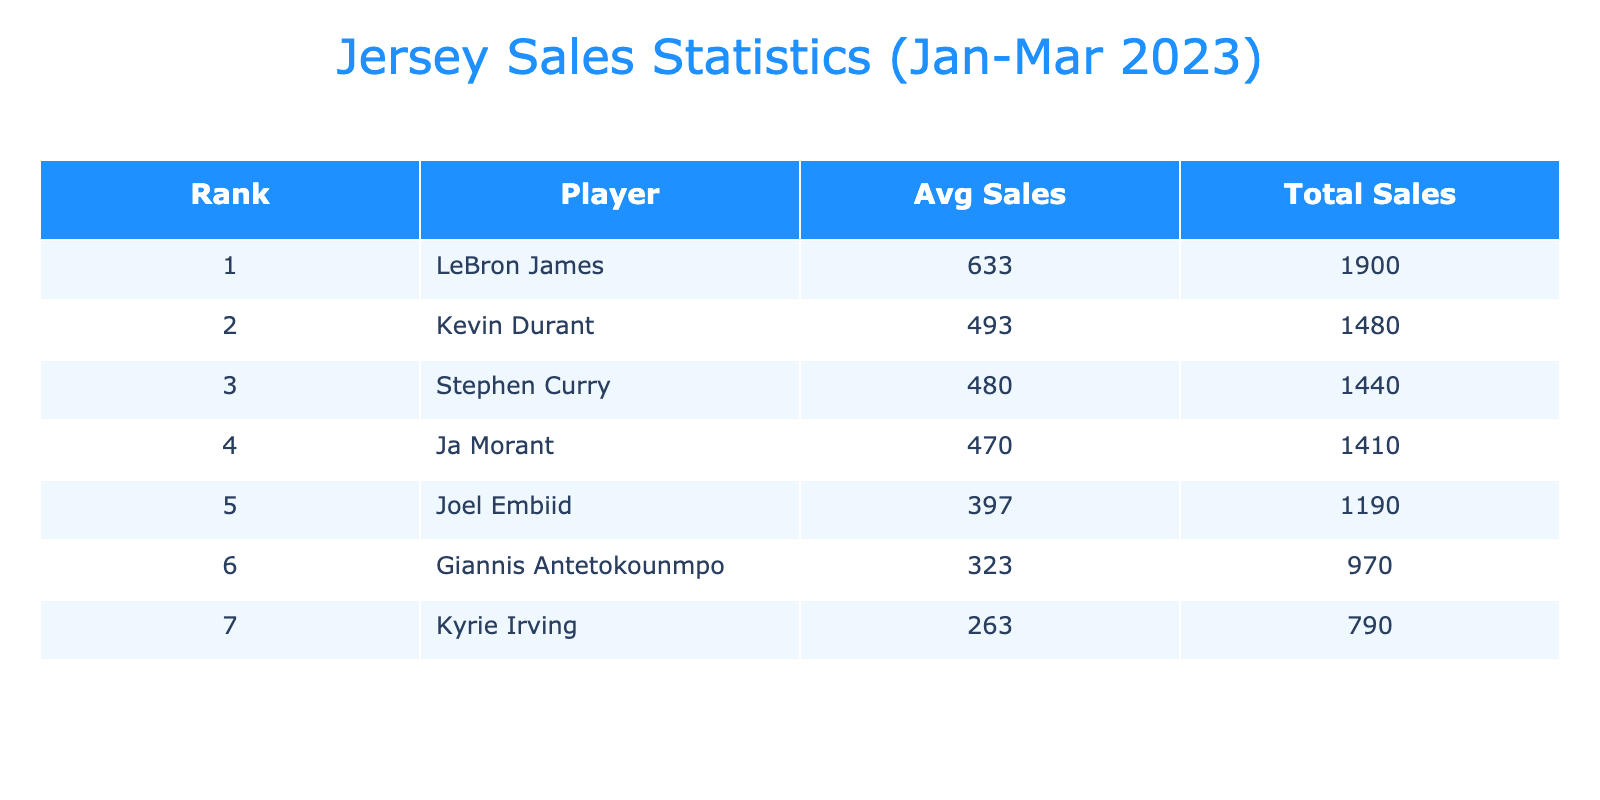What is the total jersey sales for LeBron James? From the table, we see that LeBron James has total sales of 580 + 620 + 700 = 1900.
Answer: 1900 Who had the highest average jersey sales? To determine this, we look at the average sales calculated in the table for each player. LeBron James has an average of 633.33, which is higher than any other player.
Answer: LeBron James Is the total jersey sales for Kyrie Irving greater than 800? The total sales for Kyrie Irving are 240 + 260 + 290 = 790, which is not greater than 800.
Answer: No What is the difference in average jersey sales between Stephen Curry and Kevin Durant? The average for Stephen Curry is 480, and for Kevin Durant, it is 493.33. The difference is 493.33 - 480 = 13.33.
Answer: 13.33 Which player had a rank of 3 in total sales? From the table, we see the ranks assigned to each player based on total sales, and Kevin Durant is ranked 3rd.
Answer: Kevin Durant Is the total sales of Giannis Antetokounmpo higher than that of Ja Morant? For Giannis, total sales are 300 + 320 + 350 = 970, and for Ja Morant, total sales are 410 + 480 + 520 = 1410. Since 970 is less than 1410, the answer is no.
Answer: No What is the combined average sales for all players in January? We sum the January sales: 580 (LeBron) + 450 (Stephen) + 430 (Kevin) + 300 (Giannis) + 240 (Kyrie) + 410 (Ja) + 370 (Joel) = 2880. There are 7 players, so the average is 2880 / 7 = 411.43.
Answer: 411.43 What was the total sales of all players in March? Adding the sales for March: 700 (LeBron) + 510 (Stephen) + 550 (Kevin) + 350 (Giannis) + 290 (Kyrie) + 520 (Ja) + 430 (Joel) = 3850.
Answer: 3850 Which player had a total sales of fewer than 1000 jerseys? From the total sales, Kyrie Irving with 790 and Giannis Antetokounmpo with 970 both had sales below 1000.
Answer: Kyrie Irving, Giannis Antetokounmpo 